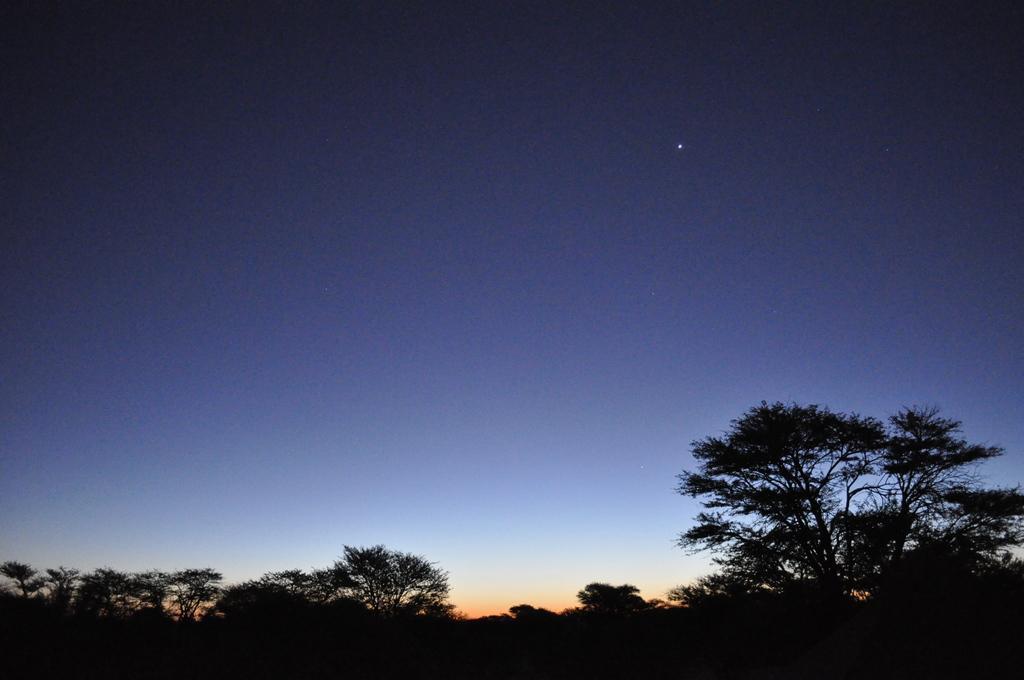Describe this image in one or two sentences. At the bottom of the image, we can see trees. In the background, there is the sky. 